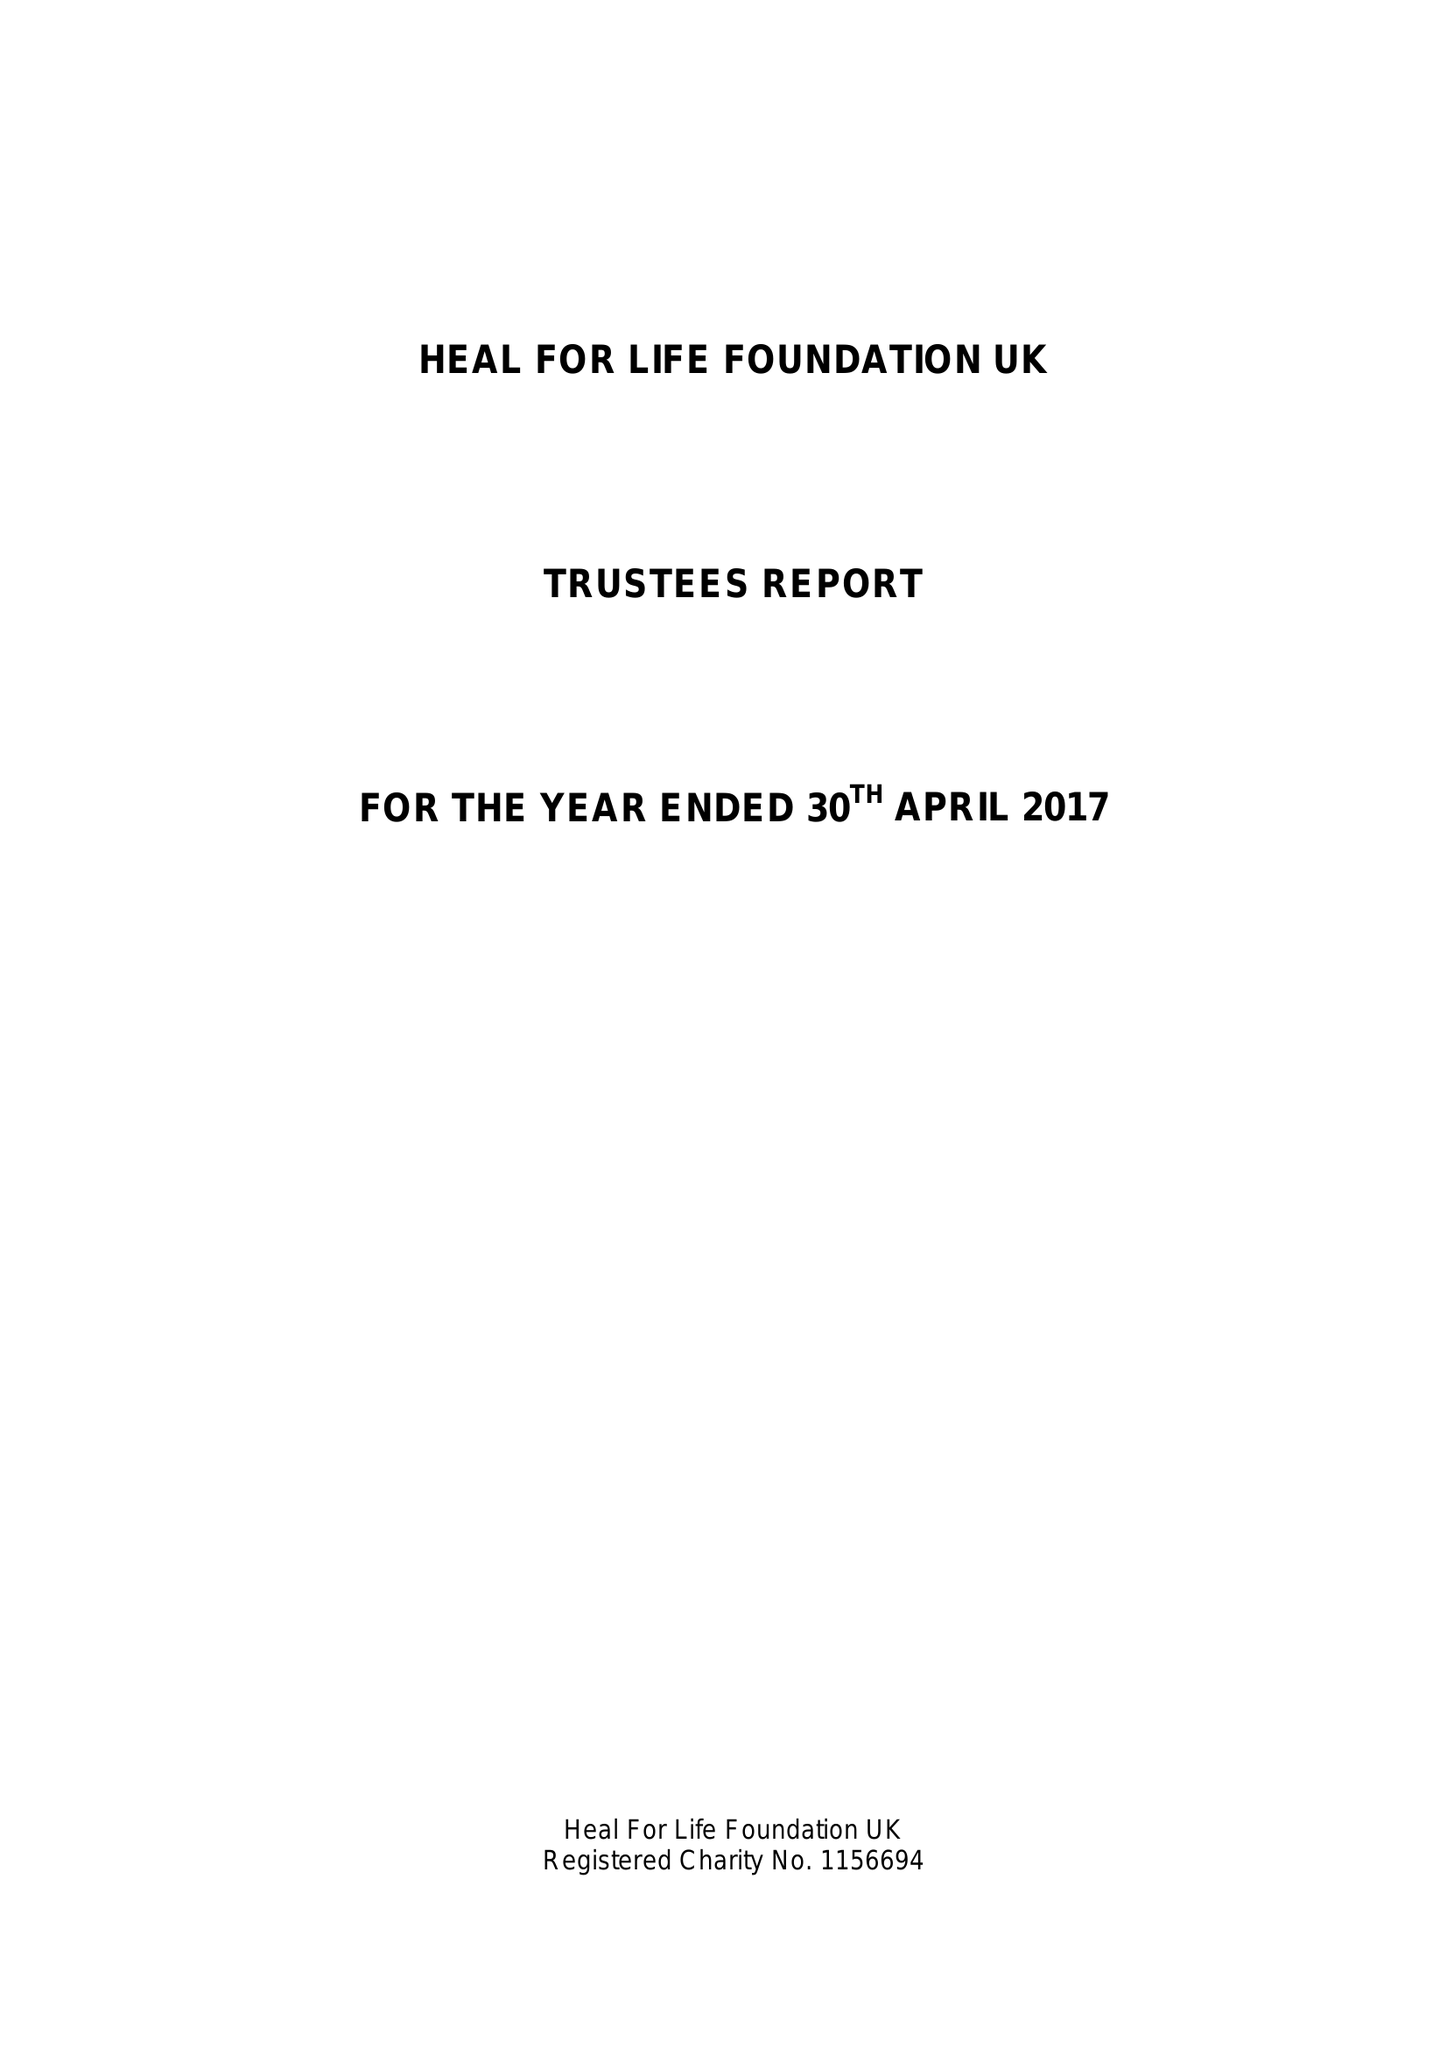What is the value for the charity_number?
Answer the question using a single word or phrase. 1156694 